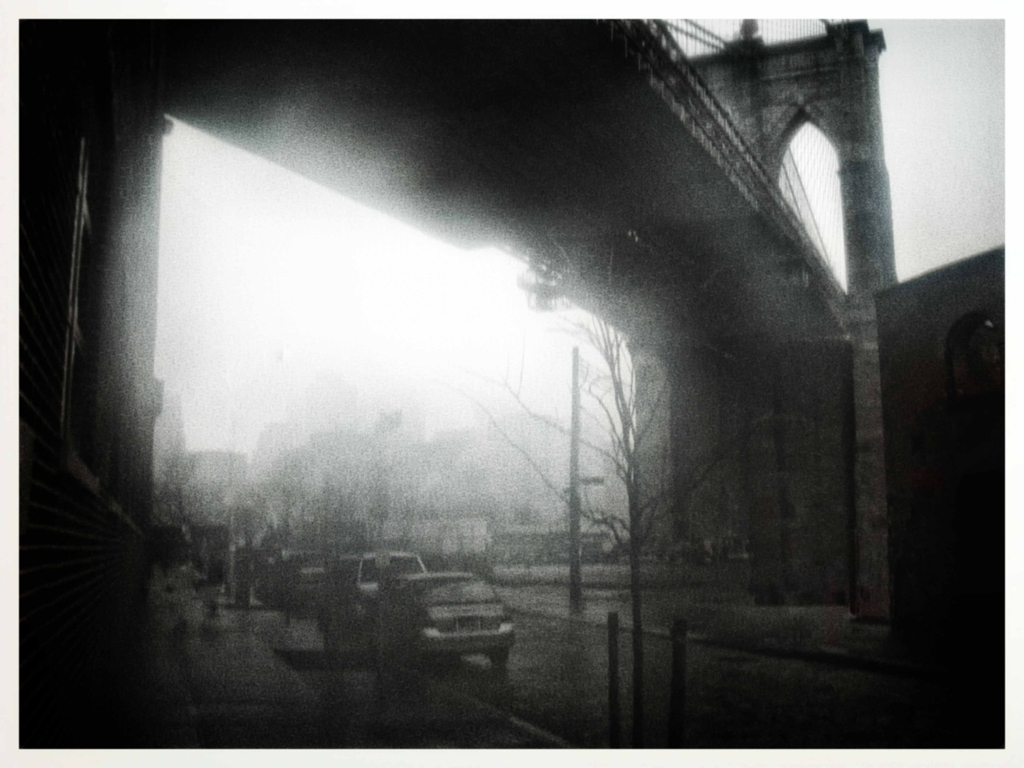What might be the historical or cultural significance of the scene depicted in the image? The bridge, given its design and majesty, might be an iconic symbol of the city it resides in, often representing the engineering achievements of its time. The scene may also reflect an urban landscape with architectural diversity, hinting at the historical layers of development. Culturally, such a bridge often becomes a part of the city’s identity, hosting countless daily crossings and becoming etched in the collective memory of its residents. 